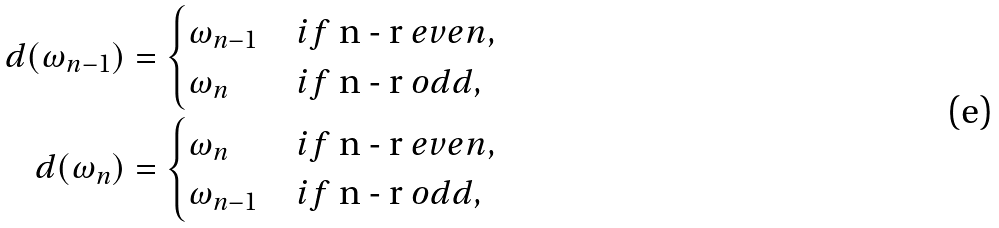<formula> <loc_0><loc_0><loc_500><loc_500>d ( \omega _ { n - 1 } ) & = \begin{cases} \omega _ { n - 1 } & i f $ n - r $ e v e n , \\ \omega _ { n } & i f $ n - r $ o d d , \end{cases} \\ d ( \omega _ { n } ) & = \begin{cases} \omega _ { n } & i f $ n - r $ e v e n , \\ \omega _ { n - 1 } & i f $ n - r $ o d d , \end{cases}</formula> 